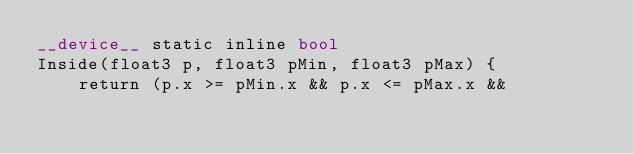Convert code to text. <code><loc_0><loc_0><loc_500><loc_500><_Cuda_>__device__ static inline bool
Inside(float3 p, float3 pMin, float3 pMax) {
    return (p.x >= pMin.x && p.x <= pMax.x &&</code> 